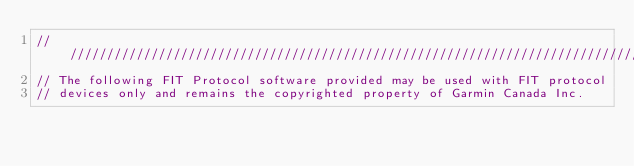<code> <loc_0><loc_0><loc_500><loc_500><_ObjectiveC_>////////////////////////////////////////////////////////////////////////////////
// The following FIT Protocol software provided may be used with FIT protocol
// devices only and remains the copyrighted property of Garmin Canada Inc.</code> 